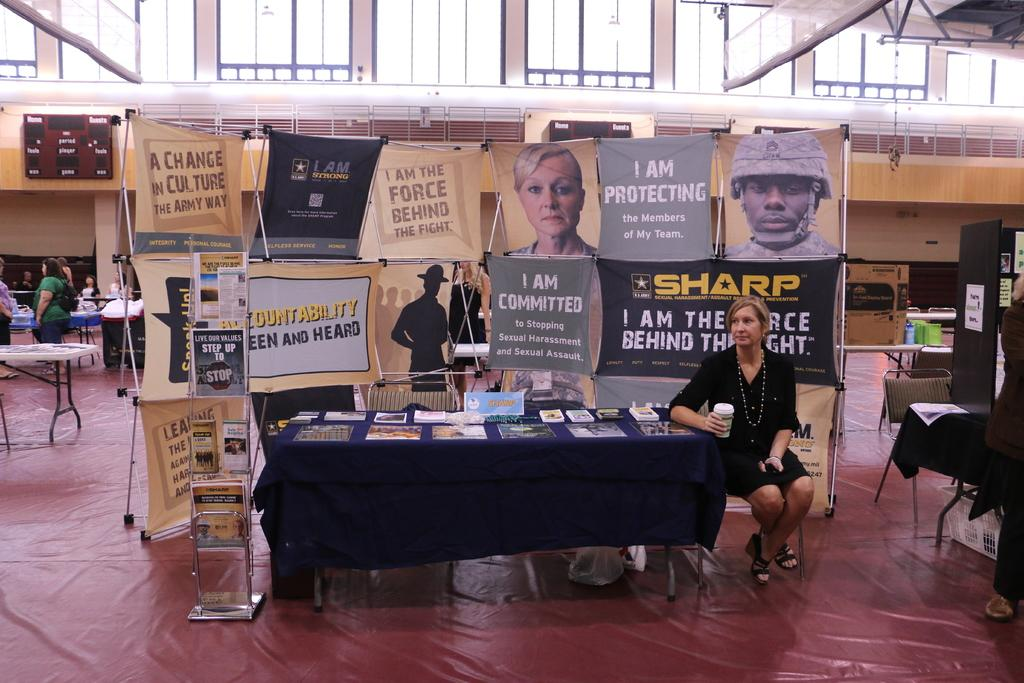What is the woman in the image doing? The woman is sitting on a chair in the image. What is located near the woman? There is a table in the image. What can be seen on the table? There are books on the table. What part of the room is visible in the image? The floor is visible in the image. How many people are present in the image? There are people in the image. What type of decorations are present in the image? There are banners in the image. What type of grape can be seen growing on the root in the image? There is no grape or root present in the image. What items are on the list that the woman is holding in the image? There is no list present in the image. 